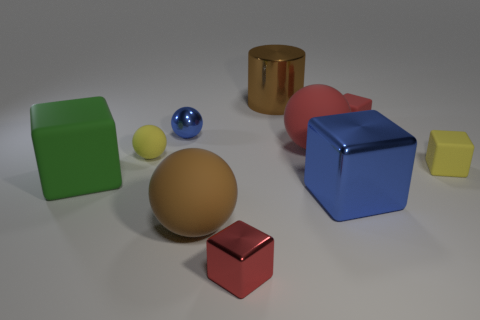How many other things are made of the same material as the red ball?
Your response must be concise. 5. Do the small red cube that is to the right of the metallic cylinder and the brown cylinder have the same material?
Give a very brief answer. No. Are there more blue metallic cubes that are behind the cylinder than blue objects that are right of the red ball?
Your answer should be very brief. No. How many things are either brown metallic things that are behind the yellow rubber cube or tiny things?
Provide a short and direct response. 6. The large brown thing that is made of the same material as the tiny blue sphere is what shape?
Make the answer very short. Cylinder. Is there any other thing that is the same shape as the big brown metal object?
Provide a short and direct response. No. What is the color of the metal object that is both to the right of the tiny red metallic block and behind the green cube?
Give a very brief answer. Brown. How many cylinders are red matte objects or tiny matte objects?
Offer a very short reply. 0. How many other matte blocks have the same size as the yellow block?
Your answer should be compact. 1. There is a red block in front of the large green rubber block; what number of yellow balls are right of it?
Offer a very short reply. 0. 